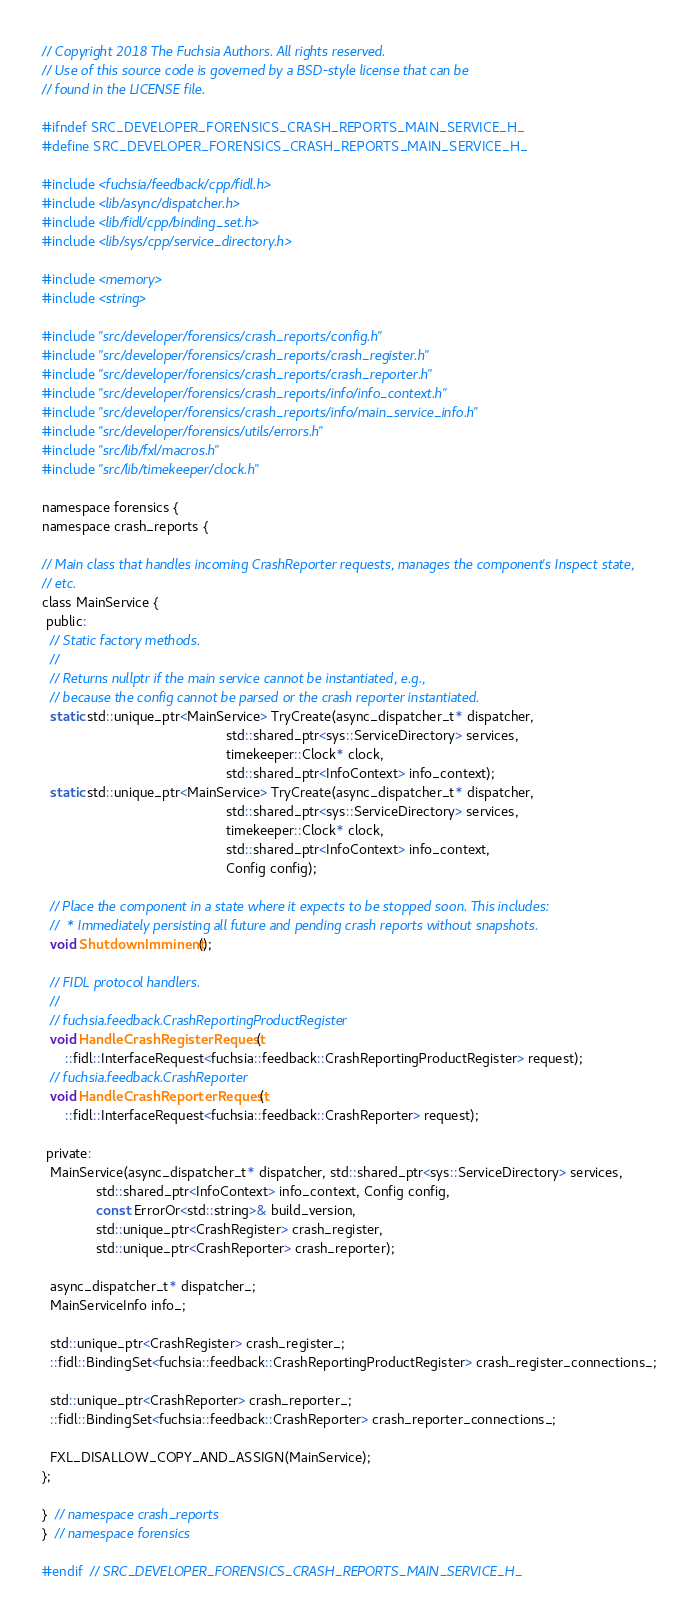<code> <loc_0><loc_0><loc_500><loc_500><_C_>// Copyright 2018 The Fuchsia Authors. All rights reserved.
// Use of this source code is governed by a BSD-style license that can be
// found in the LICENSE file.

#ifndef SRC_DEVELOPER_FORENSICS_CRASH_REPORTS_MAIN_SERVICE_H_
#define SRC_DEVELOPER_FORENSICS_CRASH_REPORTS_MAIN_SERVICE_H_

#include <fuchsia/feedback/cpp/fidl.h>
#include <lib/async/dispatcher.h>
#include <lib/fidl/cpp/binding_set.h>
#include <lib/sys/cpp/service_directory.h>

#include <memory>
#include <string>

#include "src/developer/forensics/crash_reports/config.h"
#include "src/developer/forensics/crash_reports/crash_register.h"
#include "src/developer/forensics/crash_reports/crash_reporter.h"
#include "src/developer/forensics/crash_reports/info/info_context.h"
#include "src/developer/forensics/crash_reports/info/main_service_info.h"
#include "src/developer/forensics/utils/errors.h"
#include "src/lib/fxl/macros.h"
#include "src/lib/timekeeper/clock.h"

namespace forensics {
namespace crash_reports {

// Main class that handles incoming CrashReporter requests, manages the component's Inspect state,
// etc.
class MainService {
 public:
  // Static factory methods.
  //
  // Returns nullptr if the main service cannot be instantiated, e.g.,
  // because the config cannot be parsed or the crash reporter instantiated.
  static std::unique_ptr<MainService> TryCreate(async_dispatcher_t* dispatcher,
                                                std::shared_ptr<sys::ServiceDirectory> services,
                                                timekeeper::Clock* clock,
                                                std::shared_ptr<InfoContext> info_context);
  static std::unique_ptr<MainService> TryCreate(async_dispatcher_t* dispatcher,
                                                std::shared_ptr<sys::ServiceDirectory> services,
                                                timekeeper::Clock* clock,
                                                std::shared_ptr<InfoContext> info_context,
                                                Config config);

  // Place the component in a state where it expects to be stopped soon. This includes:
  //  * Immediately persisting all future and pending crash reports without snapshots.
  void ShutdownImminent();

  // FIDL protocol handlers.
  //
  // fuchsia.feedback.CrashReportingProductRegister
  void HandleCrashRegisterRequest(
      ::fidl::InterfaceRequest<fuchsia::feedback::CrashReportingProductRegister> request);
  // fuchsia.feedback.CrashReporter
  void HandleCrashReporterRequest(
      ::fidl::InterfaceRequest<fuchsia::feedback::CrashReporter> request);

 private:
  MainService(async_dispatcher_t* dispatcher, std::shared_ptr<sys::ServiceDirectory> services,
              std::shared_ptr<InfoContext> info_context, Config config,
              const ErrorOr<std::string>& build_version,
              std::unique_ptr<CrashRegister> crash_register,
              std::unique_ptr<CrashReporter> crash_reporter);

  async_dispatcher_t* dispatcher_;
  MainServiceInfo info_;

  std::unique_ptr<CrashRegister> crash_register_;
  ::fidl::BindingSet<fuchsia::feedback::CrashReportingProductRegister> crash_register_connections_;

  std::unique_ptr<CrashReporter> crash_reporter_;
  ::fidl::BindingSet<fuchsia::feedback::CrashReporter> crash_reporter_connections_;

  FXL_DISALLOW_COPY_AND_ASSIGN(MainService);
};

}  // namespace crash_reports
}  // namespace forensics

#endif  // SRC_DEVELOPER_FORENSICS_CRASH_REPORTS_MAIN_SERVICE_H_
</code> 